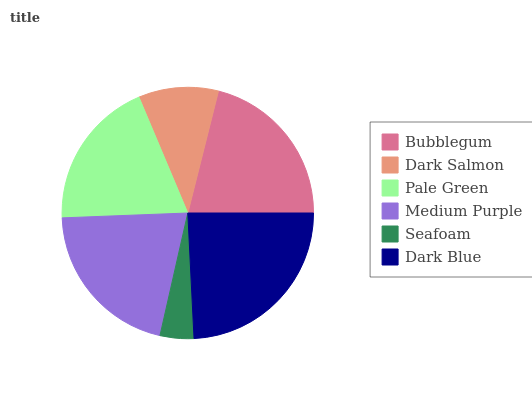Is Seafoam the minimum?
Answer yes or no. Yes. Is Dark Blue the maximum?
Answer yes or no. Yes. Is Dark Salmon the minimum?
Answer yes or no. No. Is Dark Salmon the maximum?
Answer yes or no. No. Is Bubblegum greater than Dark Salmon?
Answer yes or no. Yes. Is Dark Salmon less than Bubblegum?
Answer yes or no. Yes. Is Dark Salmon greater than Bubblegum?
Answer yes or no. No. Is Bubblegum less than Dark Salmon?
Answer yes or no. No. Is Medium Purple the high median?
Answer yes or no. Yes. Is Pale Green the low median?
Answer yes or no. Yes. Is Seafoam the high median?
Answer yes or no. No. Is Medium Purple the low median?
Answer yes or no. No. 